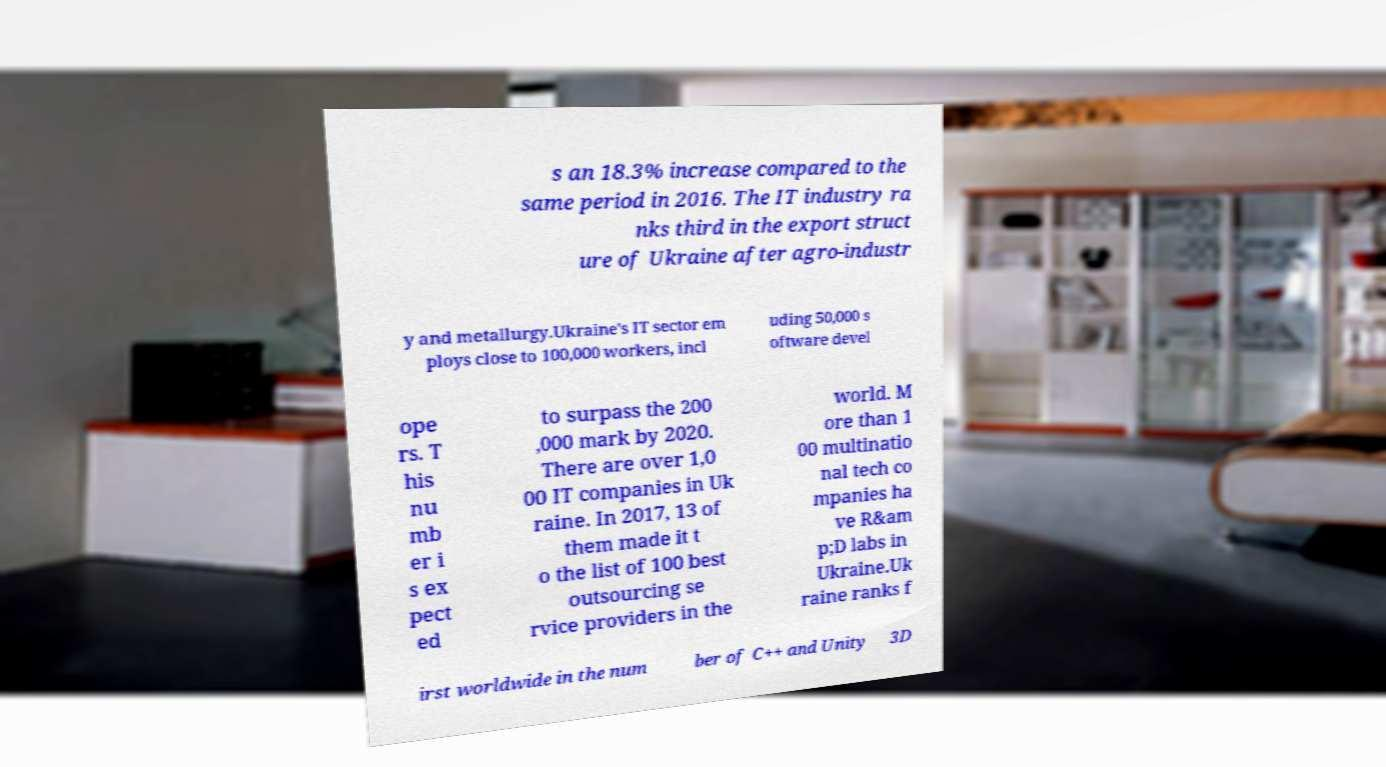Can you read and provide the text displayed in the image?This photo seems to have some interesting text. Can you extract and type it out for me? s an 18.3% increase compared to the same period in 2016. The IT industry ra nks third in the export struct ure of Ukraine after agro-industr y and metallurgy.Ukraine's IT sector em ploys close to 100,000 workers, incl uding 50,000 s oftware devel ope rs. T his nu mb er i s ex pect ed to surpass the 200 ,000 mark by 2020. There are over 1,0 00 IT companies in Uk raine. In 2017, 13 of them made it t o the list of 100 best outsourcing se rvice providers in the world. M ore than 1 00 multinatio nal tech co mpanies ha ve R&am p;D labs in Ukraine.Uk raine ranks f irst worldwide in the num ber of C++ and Unity 3D 